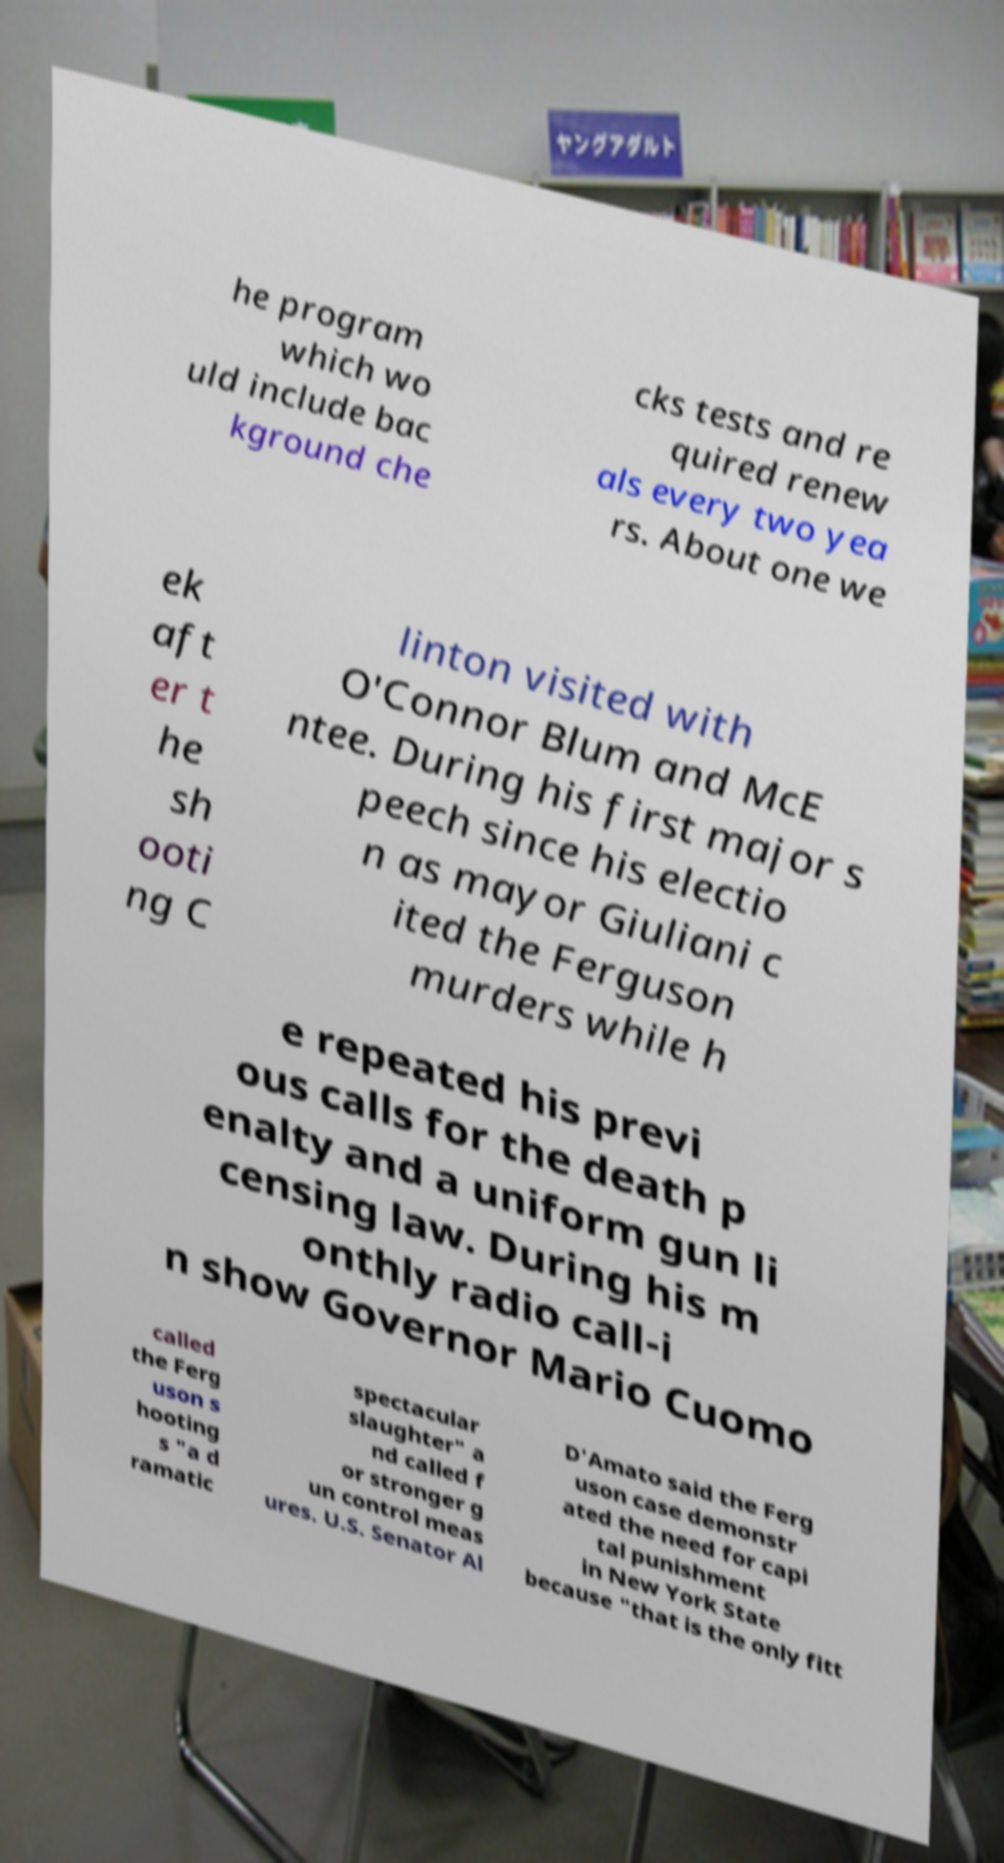For documentation purposes, I need the text within this image transcribed. Could you provide that? he program which wo uld include bac kground che cks tests and re quired renew als every two yea rs. About one we ek aft er t he sh ooti ng C linton visited with O'Connor Blum and McE ntee. During his first major s peech since his electio n as mayor Giuliani c ited the Ferguson murders while h e repeated his previ ous calls for the death p enalty and a uniform gun li censing law. During his m onthly radio call-i n show Governor Mario Cuomo called the Ferg uson s hooting s "a d ramatic spectacular slaughter" a nd called f or stronger g un control meas ures. U.S. Senator Al D'Amato said the Ferg uson case demonstr ated the need for capi tal punishment in New York State because "that is the only fitt 